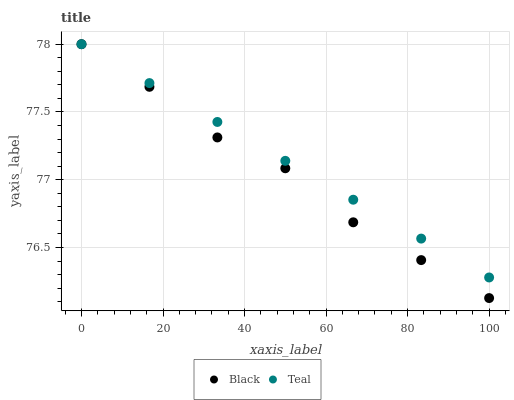Does Black have the minimum area under the curve?
Answer yes or no. Yes. Does Teal have the maximum area under the curve?
Answer yes or no. Yes. Does Teal have the minimum area under the curve?
Answer yes or no. No. Is Teal the smoothest?
Answer yes or no. Yes. Is Black the roughest?
Answer yes or no. Yes. Is Teal the roughest?
Answer yes or no. No. Does Black have the lowest value?
Answer yes or no. Yes. Does Teal have the lowest value?
Answer yes or no. No. Does Teal have the highest value?
Answer yes or no. Yes. Does Black intersect Teal?
Answer yes or no. Yes. Is Black less than Teal?
Answer yes or no. No. Is Black greater than Teal?
Answer yes or no. No. 